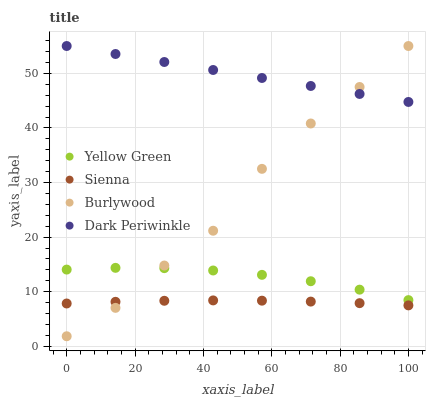Does Sienna have the minimum area under the curve?
Answer yes or no. Yes. Does Dark Periwinkle have the maximum area under the curve?
Answer yes or no. Yes. Does Burlywood have the minimum area under the curve?
Answer yes or no. No. Does Burlywood have the maximum area under the curve?
Answer yes or no. No. Is Dark Periwinkle the smoothest?
Answer yes or no. Yes. Is Burlywood the roughest?
Answer yes or no. Yes. Is Yellow Green the smoothest?
Answer yes or no. No. Is Yellow Green the roughest?
Answer yes or no. No. Does Burlywood have the lowest value?
Answer yes or no. Yes. Does Yellow Green have the lowest value?
Answer yes or no. No. Does Dark Periwinkle have the highest value?
Answer yes or no. Yes. Does Yellow Green have the highest value?
Answer yes or no. No. Is Sienna less than Yellow Green?
Answer yes or no. Yes. Is Dark Periwinkle greater than Sienna?
Answer yes or no. Yes. Does Sienna intersect Burlywood?
Answer yes or no. Yes. Is Sienna less than Burlywood?
Answer yes or no. No. Is Sienna greater than Burlywood?
Answer yes or no. No. Does Sienna intersect Yellow Green?
Answer yes or no. No. 